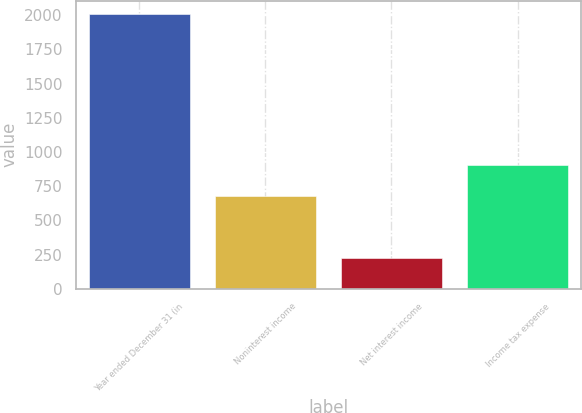Convert chart. <chart><loc_0><loc_0><loc_500><loc_500><bar_chart><fcel>Year ended December 31 (in<fcel>Noninterest income<fcel>Net interest income<fcel>Income tax expense<nl><fcel>2006<fcel>676<fcel>228<fcel>904<nl></chart> 